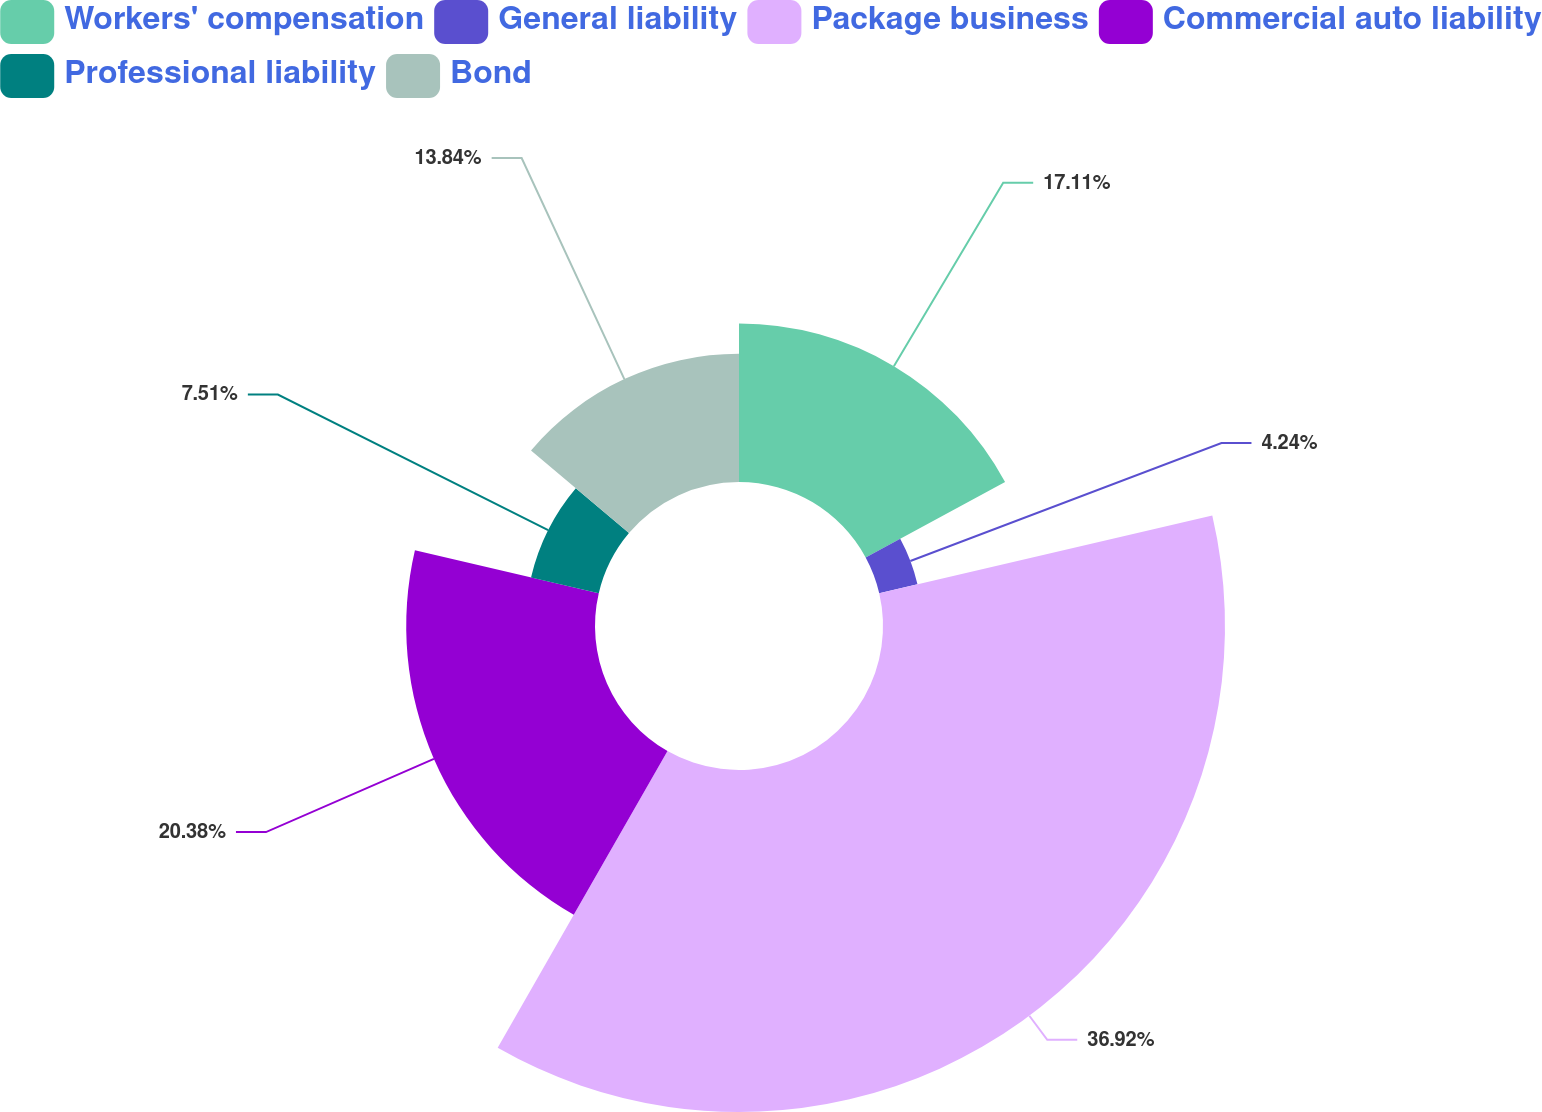Convert chart to OTSL. <chart><loc_0><loc_0><loc_500><loc_500><pie_chart><fcel>Workers' compensation<fcel>General liability<fcel>Package business<fcel>Commercial auto liability<fcel>Professional liability<fcel>Bond<nl><fcel>17.11%<fcel>4.24%<fcel>36.92%<fcel>20.38%<fcel>7.51%<fcel>13.84%<nl></chart> 